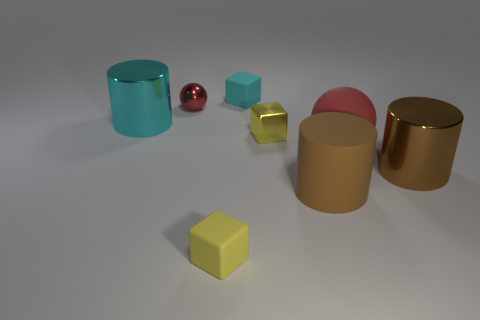Add 2 tiny purple shiny spheres. How many objects exist? 10 Subtract all cylinders. How many objects are left? 5 Subtract all large matte cylinders. Subtract all cylinders. How many objects are left? 4 Add 6 blocks. How many blocks are left? 9 Add 8 small purple matte cylinders. How many small purple matte cylinders exist? 8 Subtract 0 yellow balls. How many objects are left? 8 